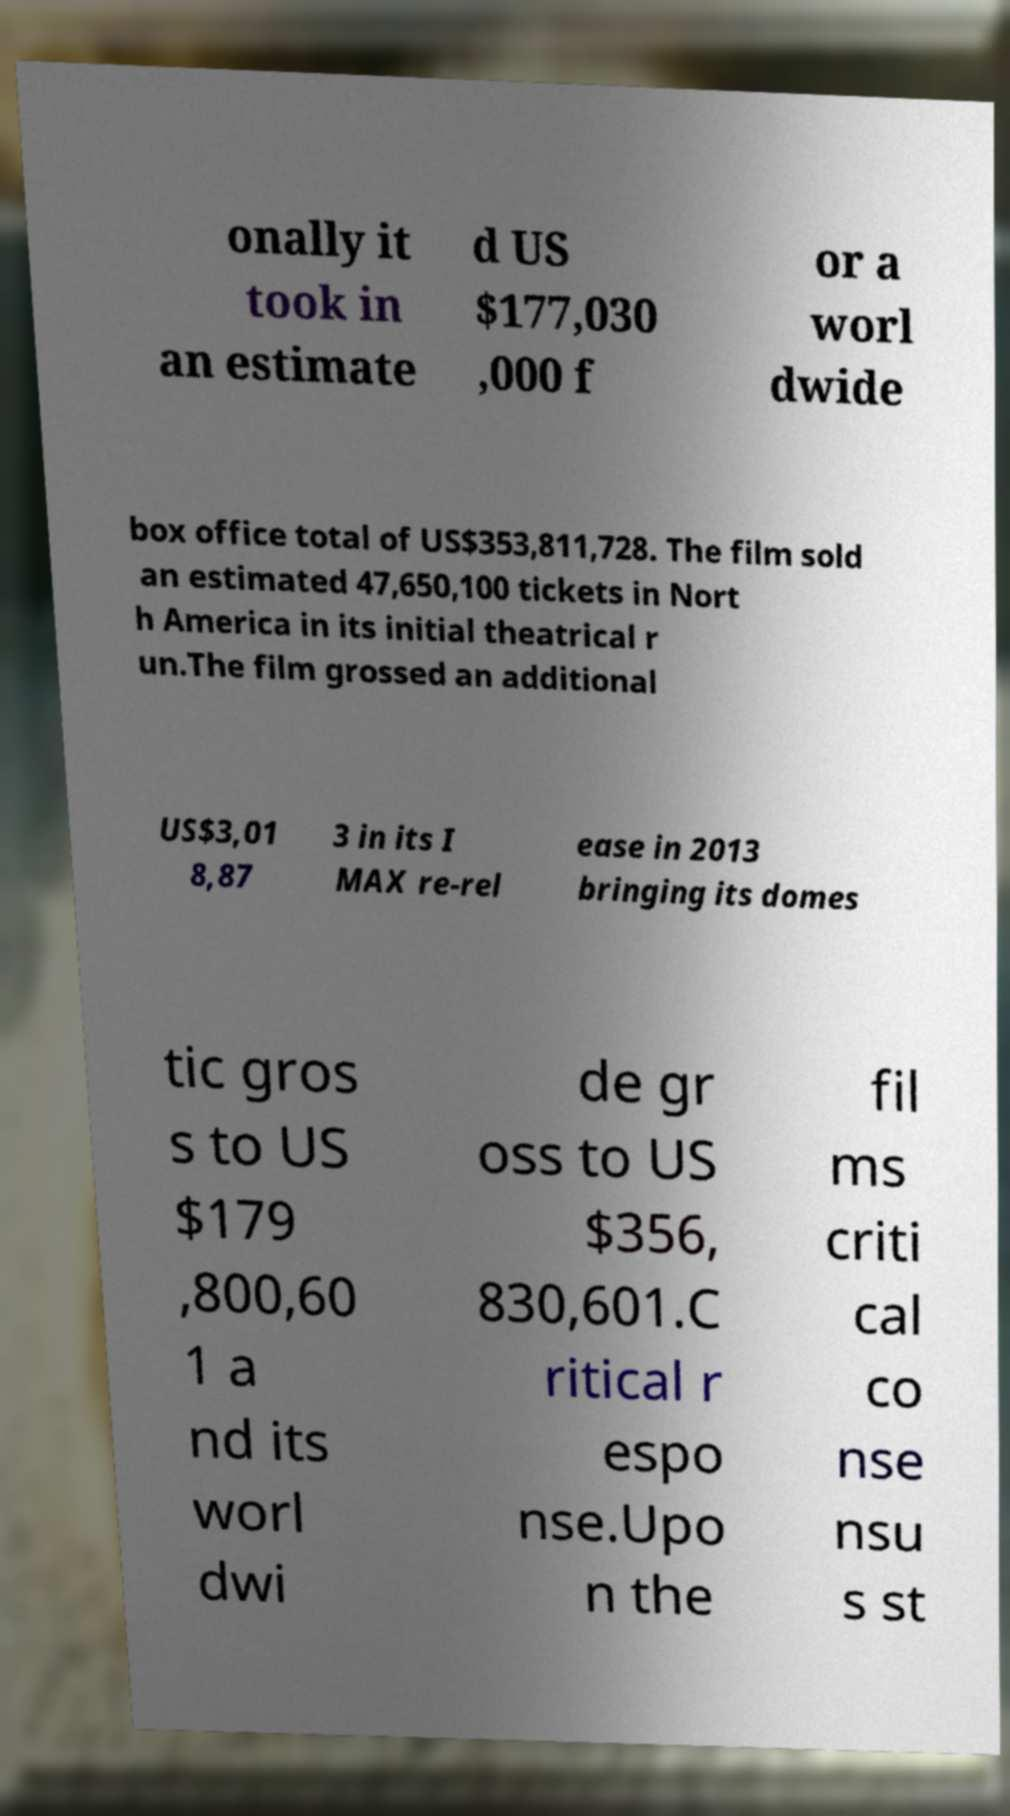I need the written content from this picture converted into text. Can you do that? onally it took in an estimate d US $177,030 ,000 f or a worl dwide box office total of US$353,811,728. The film sold an estimated 47,650,100 tickets in Nort h America in its initial theatrical r un.The film grossed an additional US$3,01 8,87 3 in its I MAX re-rel ease in 2013 bringing its domes tic gros s to US $179 ,800,60 1 a nd its worl dwi de gr oss to US $356, 830,601.C ritical r espo nse.Upo n the fil ms criti cal co nse nsu s st 